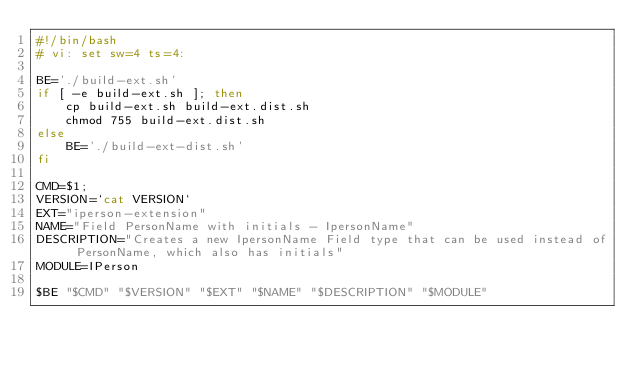Convert code to text. <code><loc_0><loc_0><loc_500><loc_500><_Bash_>#!/bin/bash
# vi: set sw=4 ts=4:

BE='./build-ext.sh'
if [ -e build-ext.sh ]; then
    cp build-ext.sh build-ext.dist.sh
    chmod 755 build-ext.dist.sh
else
    BE='./build-ext-dist.sh'
fi

CMD=$1;
VERSION=`cat VERSION`
EXT="iperson-extension"
NAME="Field PersonName with initials - IpersonName"
DESCRIPTION="Creates a new IpersonName Field type that can be used instead of PersonName, which also has initials"
MODULE=IPerson

$BE "$CMD" "$VERSION" "$EXT" "$NAME" "$DESCRIPTION" "$MODULE"

</code> 